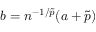<formula> <loc_0><loc_0><loc_500><loc_500>b = n ^ { - 1 / \tilde { p } } ( a + \tilde { p } )</formula> 